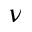Convert formula to latex. <formula><loc_0><loc_0><loc_500><loc_500>\nu</formula> 